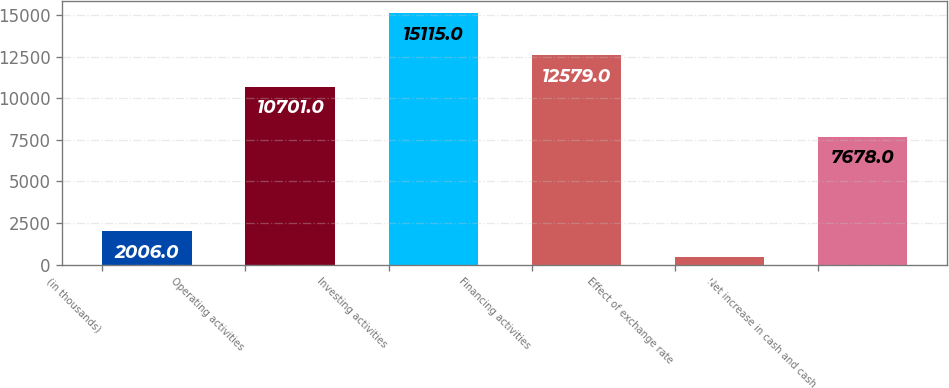Convert chart to OTSL. <chart><loc_0><loc_0><loc_500><loc_500><bar_chart><fcel>(in thousands)<fcel>Operating activities<fcel>Investing activities<fcel>Financing activities<fcel>Effect of exchange rate<fcel>Net increase in cash and cash<nl><fcel>2006<fcel>10701<fcel>15115<fcel>12579<fcel>487<fcel>7678<nl></chart> 